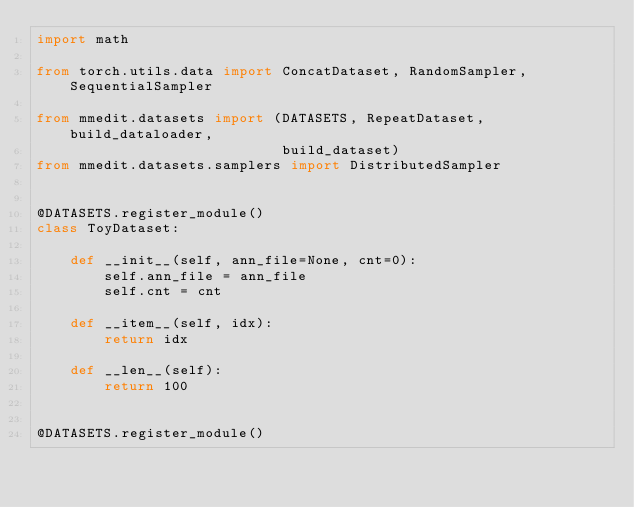Convert code to text. <code><loc_0><loc_0><loc_500><loc_500><_Python_>import math

from torch.utils.data import ConcatDataset, RandomSampler, SequentialSampler

from mmedit.datasets import (DATASETS, RepeatDataset, build_dataloader,
                             build_dataset)
from mmedit.datasets.samplers import DistributedSampler


@DATASETS.register_module()
class ToyDataset:

    def __init__(self, ann_file=None, cnt=0):
        self.ann_file = ann_file
        self.cnt = cnt

    def __item__(self, idx):
        return idx

    def __len__(self):
        return 100


@DATASETS.register_module()</code> 